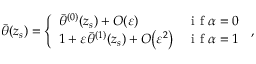<formula> <loc_0><loc_0><loc_500><loc_500>\begin{array} { r } { \bar { \theta } ( z _ { s } ) = \left \{ \begin{array} { l l } { \bar { \theta } ^ { ( 0 ) } ( z _ { s } ) + { O } \, \left ( { \varepsilon } \right ) } & { i f \alpha = 0 } \\ { 1 + { \varepsilon } \bar { \theta } ^ { ( 1 ) } ( z _ { s } ) + { O } \, \left ( { \varepsilon } ^ { 2 } \right ) } & { i f \alpha = 1 } \end{array} \, , } \end{array}</formula> 